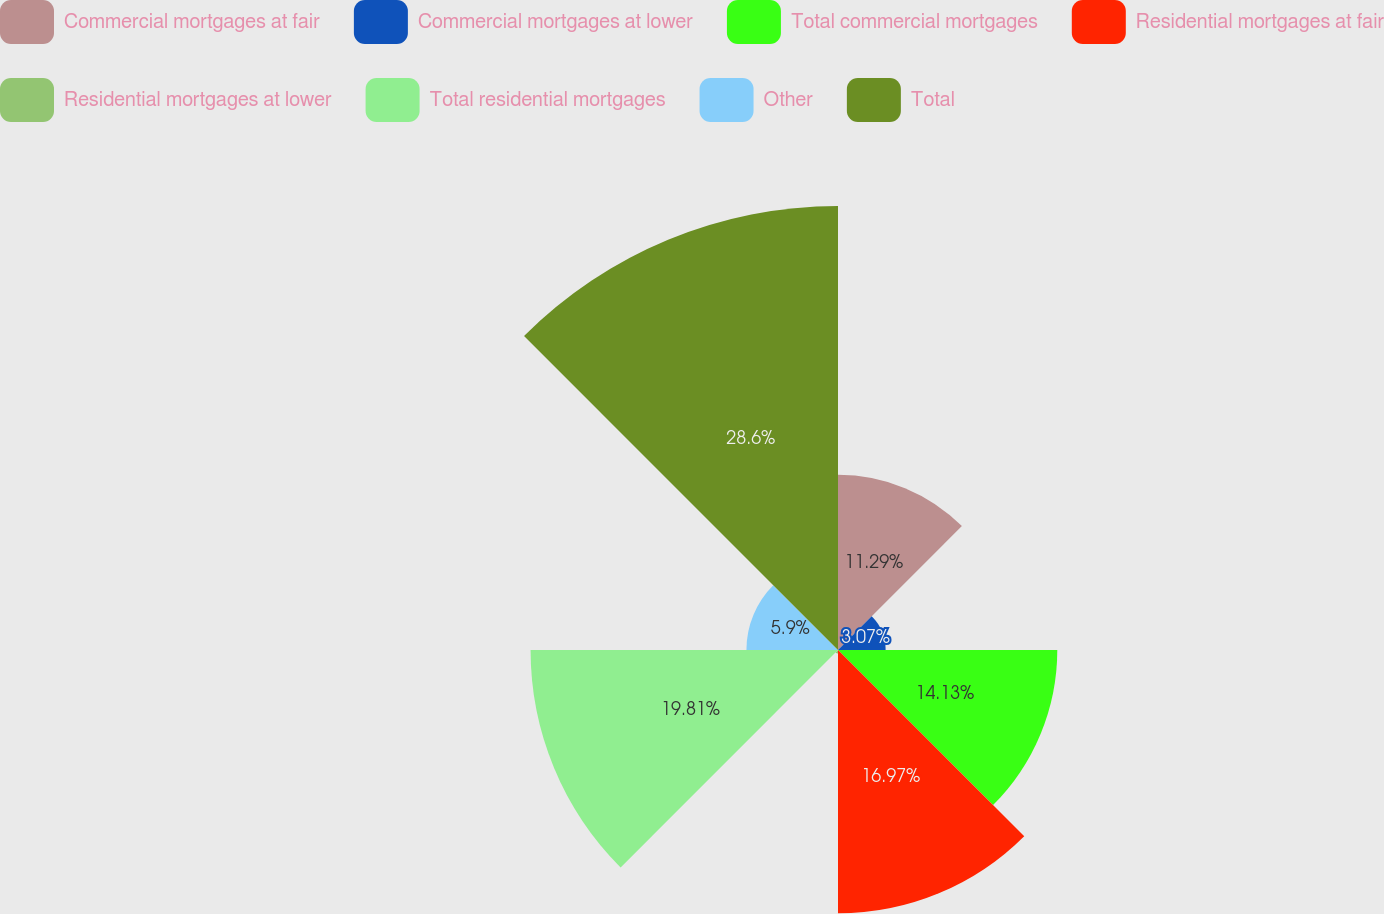Convert chart. <chart><loc_0><loc_0><loc_500><loc_500><pie_chart><fcel>Commercial mortgages at fair<fcel>Commercial mortgages at lower<fcel>Total commercial mortgages<fcel>Residential mortgages at fair<fcel>Residential mortgages at lower<fcel>Total residential mortgages<fcel>Other<fcel>Total<nl><fcel>11.29%<fcel>3.07%<fcel>14.13%<fcel>16.97%<fcel>0.23%<fcel>19.81%<fcel>5.9%<fcel>28.61%<nl></chart> 